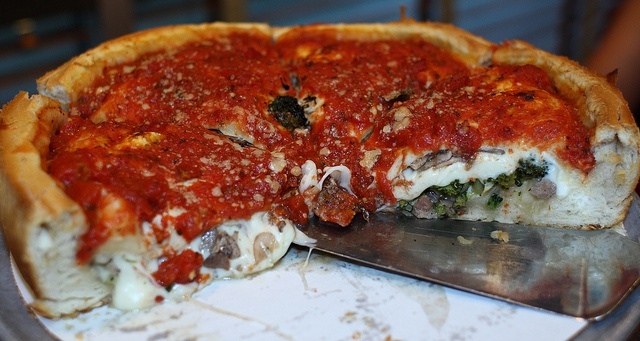Describe the objects in this image and their specific colors. I can see pizza in black, maroon, brown, and darkgray tones and people in maroon and black tones in this image. 